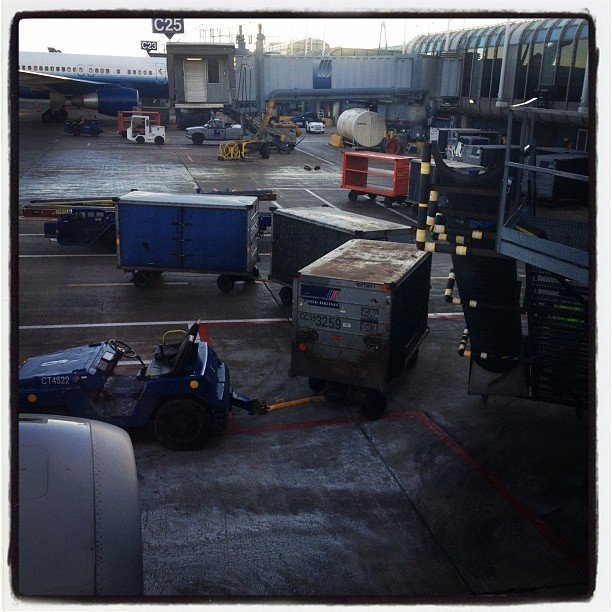Describe the objects in this image and their specific colors. I can see truck in white, black, gray, and darkgray tones, truck in white, black, and gray tones, airplane in white, black, lightgray, navy, and darkgray tones, truck in white, gray, black, and darkgray tones, and truck in white, gray, black, and darkblue tones in this image. 